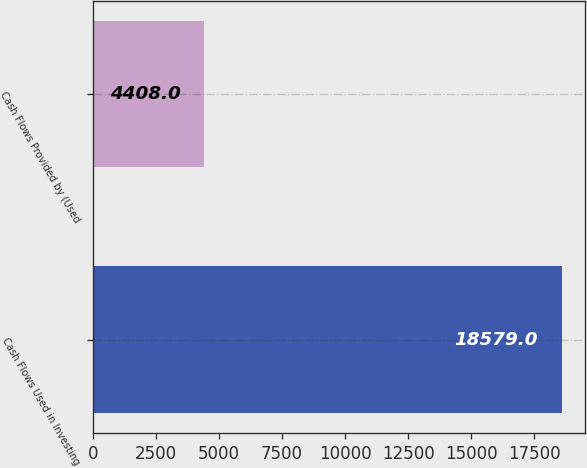Convert chart to OTSL. <chart><loc_0><loc_0><loc_500><loc_500><bar_chart><fcel>Cash Flows Used in Investing<fcel>Cash Flows Provided by (Used<nl><fcel>18579<fcel>4408<nl></chart> 